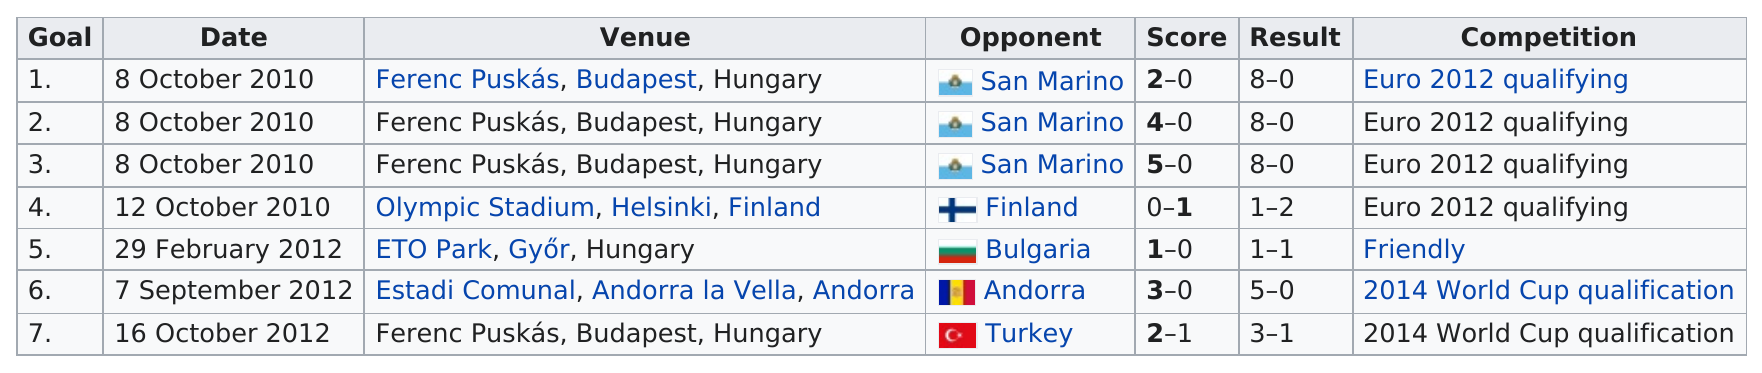List a handful of essential elements in this visual. In 2012, Ádám Szalai scored his next international goal after 2010. He scored in 1 non-qualifying game. Szalai scored only one more international goal against all other countries combined than he did against San Marino, a country with a population smaller than that of many cities. Szalai scored the majority of his international goals during the qualifying rounds for Euro 2012 and 2014 World Cup, showcasing his proficiency at multiple levels of play. In what year was Szalai's first international goal scored? In the year 2010, Szalai scored his first international goal. 